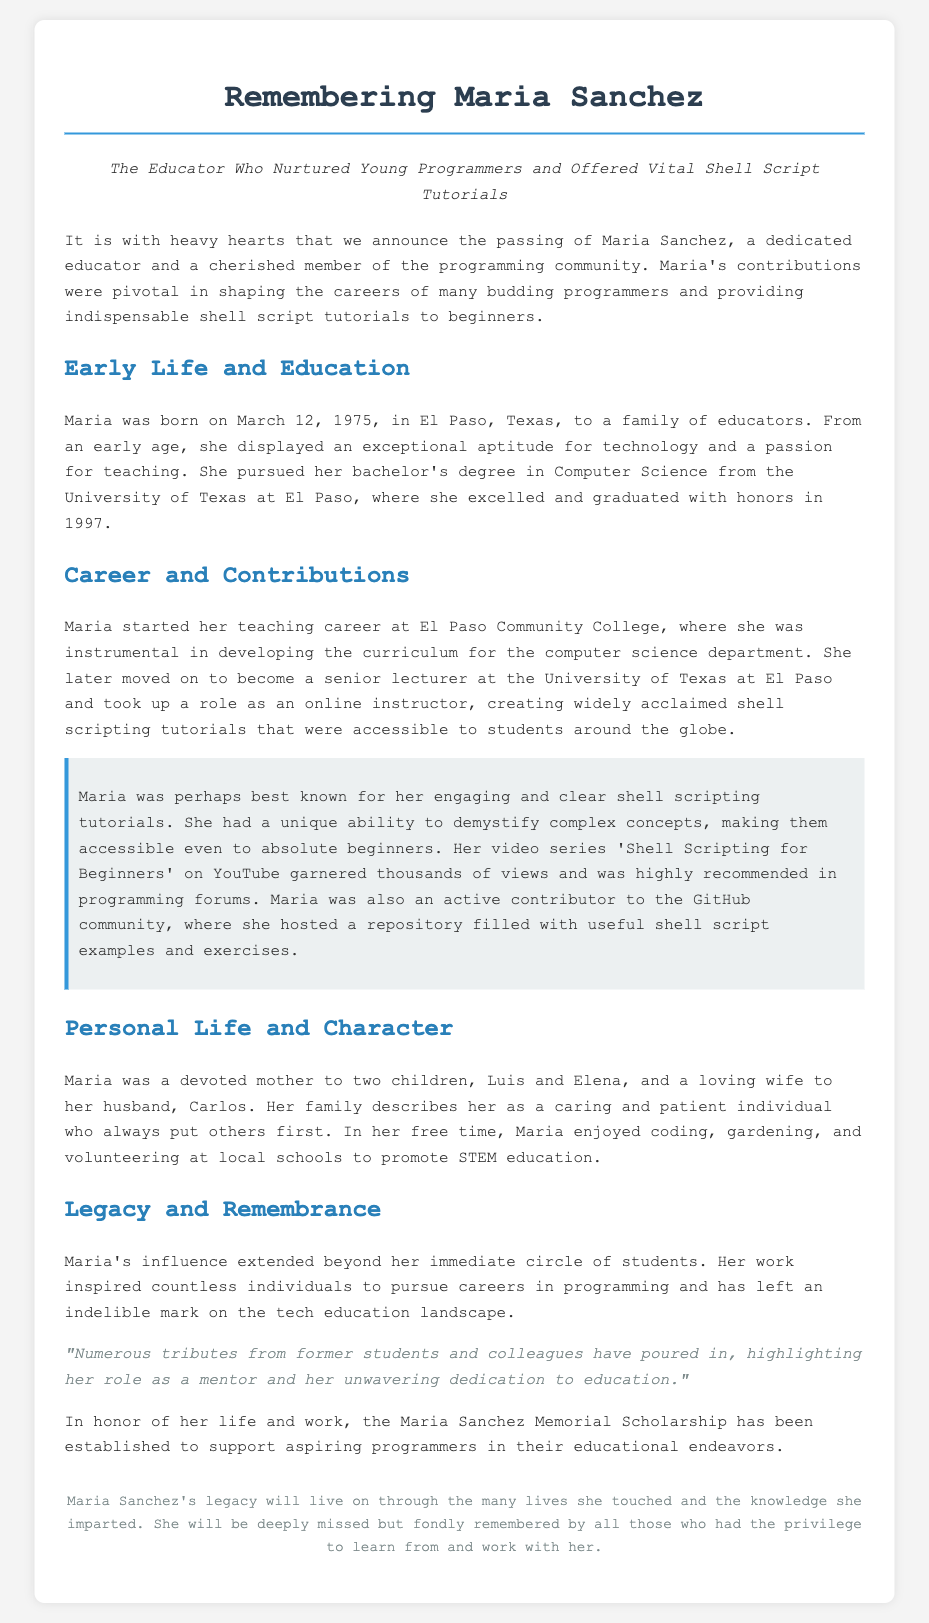What was Maria Sanchez's profession? The document states her profession as an educator and a member of the programming community.
Answer: Educator When was Maria born? The document specifies her birth date as March 12, 1975.
Answer: March 12, 1975 Where did Maria complete her bachelor's degree? The document mentions she graduated from the University of Texas at El Paso.
Answer: University of Texas at El Paso What notable tutorial series did Maria create? The document refers to her video series as 'Shell Scripting for Beginners'.
Answer: Shell Scripting for Beginners How many children did Maria have? The document mentions that she was a mother to two children.
Answer: Two What scholarship was established in Maria's honor? The document notes the creation of the Maria Sanchez Memorial Scholarship.
Answer: Maria Sanchez Memorial Scholarship How did Maria influence aspiring programmers? The document discusses her pivotal contributions in shaping careers through education and tutorials.
Answer: Shaping careers What was Maria's role in her family? The document describes her as a devoted mother and loving wife.
Answer: Devoted mother What type of community contributions did Maria make? The document describes her volunteering at local schools to promote STEM education.
Answer: Volunteering at local schools 